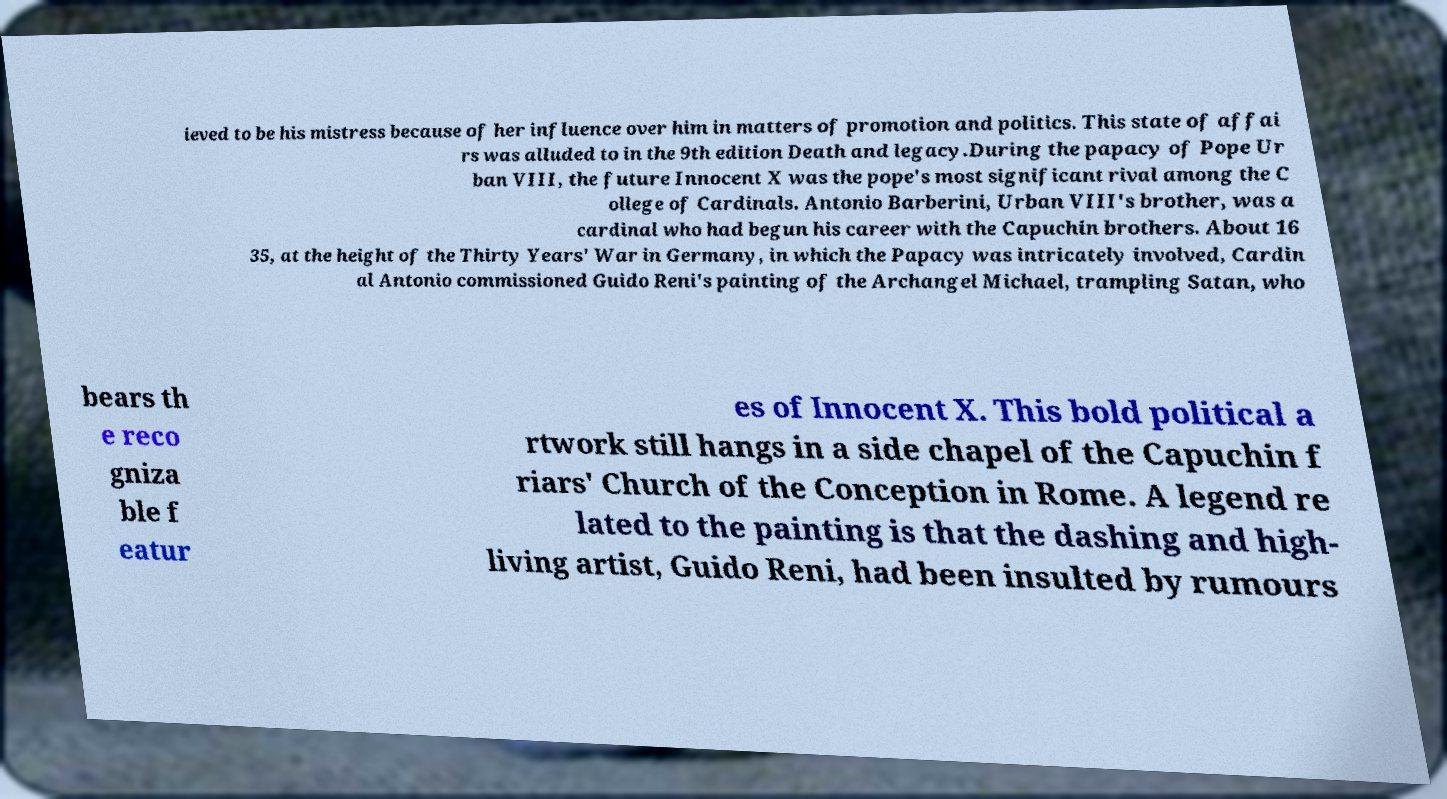Could you assist in decoding the text presented in this image and type it out clearly? ieved to be his mistress because of her influence over him in matters of promotion and politics. This state of affai rs was alluded to in the 9th edition Death and legacy.During the papacy of Pope Ur ban VIII, the future Innocent X was the pope's most significant rival among the C ollege of Cardinals. Antonio Barberini, Urban VIII's brother, was a cardinal who had begun his career with the Capuchin brothers. About 16 35, at the height of the Thirty Years' War in Germany, in which the Papacy was intricately involved, Cardin al Antonio commissioned Guido Reni's painting of the Archangel Michael, trampling Satan, who bears th e reco gniza ble f eatur es of Innocent X. This bold political a rtwork still hangs in a side chapel of the Capuchin f riars' Church of the Conception in Rome. A legend re lated to the painting is that the dashing and high- living artist, Guido Reni, had been insulted by rumours 